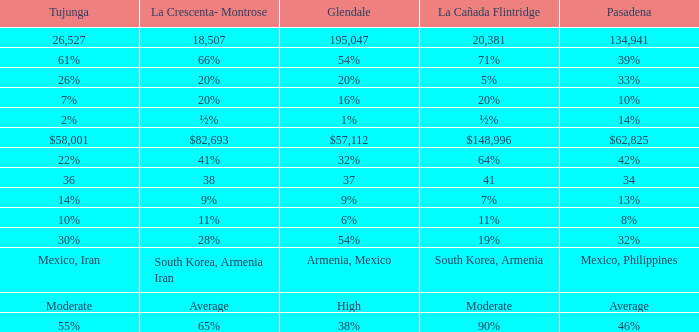What is the percentage of Tujunja when Pasadena is 33%? 26%. 